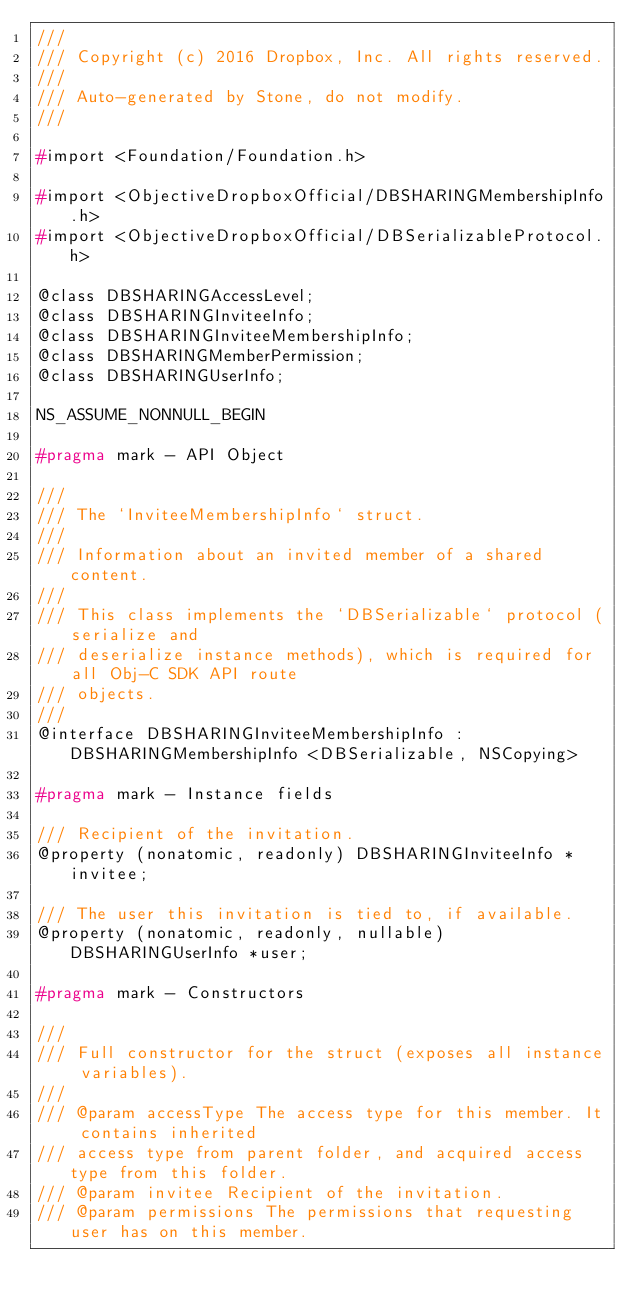<code> <loc_0><loc_0><loc_500><loc_500><_C_>///
/// Copyright (c) 2016 Dropbox, Inc. All rights reserved.
///
/// Auto-generated by Stone, do not modify.
///

#import <Foundation/Foundation.h>

#import <ObjectiveDropboxOfficial/DBSHARINGMembershipInfo.h>
#import <ObjectiveDropboxOfficial/DBSerializableProtocol.h>

@class DBSHARINGAccessLevel;
@class DBSHARINGInviteeInfo;
@class DBSHARINGInviteeMembershipInfo;
@class DBSHARINGMemberPermission;
@class DBSHARINGUserInfo;

NS_ASSUME_NONNULL_BEGIN

#pragma mark - API Object

///
/// The `InviteeMembershipInfo` struct.
///
/// Information about an invited member of a shared content.
///
/// This class implements the `DBSerializable` protocol (serialize and
/// deserialize instance methods), which is required for all Obj-C SDK API route
/// objects.
///
@interface DBSHARINGInviteeMembershipInfo : DBSHARINGMembershipInfo <DBSerializable, NSCopying>

#pragma mark - Instance fields

/// Recipient of the invitation.
@property (nonatomic, readonly) DBSHARINGInviteeInfo *invitee;

/// The user this invitation is tied to, if available.
@property (nonatomic, readonly, nullable) DBSHARINGUserInfo *user;

#pragma mark - Constructors

///
/// Full constructor for the struct (exposes all instance variables).
///
/// @param accessType The access type for this member. It contains inherited
/// access type from parent folder, and acquired access type from this folder.
/// @param invitee Recipient of the invitation.
/// @param permissions The permissions that requesting user has on this member.</code> 